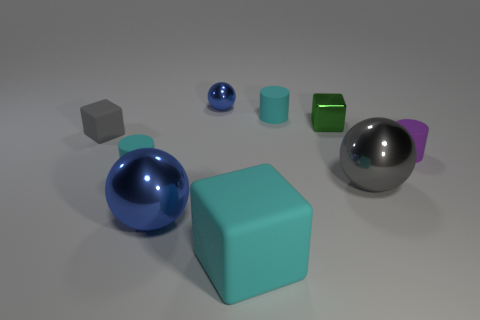Subtract all green cubes. How many blue spheres are left? 2 Subtract all purple cylinders. How many cylinders are left? 2 Add 1 purple matte cylinders. How many objects exist? 10 Subtract all blocks. How many objects are left? 6 Subtract all purple cubes. Subtract all cyan cylinders. How many cubes are left? 3 Add 4 rubber things. How many rubber things are left? 9 Add 7 large red metal things. How many large red metal things exist? 7 Subtract 0 yellow cylinders. How many objects are left? 9 Subtract all small gray shiny balls. Subtract all rubber objects. How many objects are left? 4 